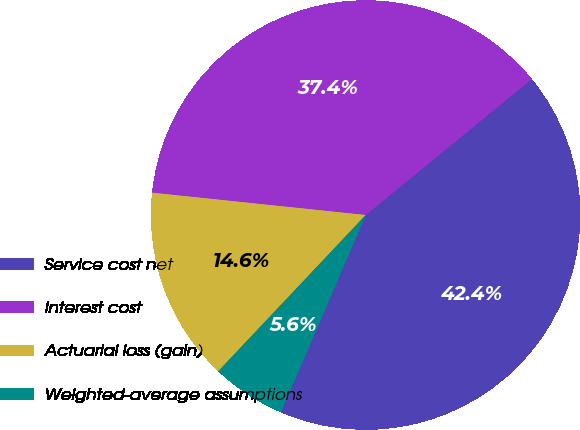<chart> <loc_0><loc_0><loc_500><loc_500><pie_chart><fcel>Service cost net<fcel>Interest cost<fcel>Actuarial loss (gain)<fcel>Weighted-average assumptions<nl><fcel>42.38%<fcel>37.42%<fcel>14.62%<fcel>5.58%<nl></chart> 